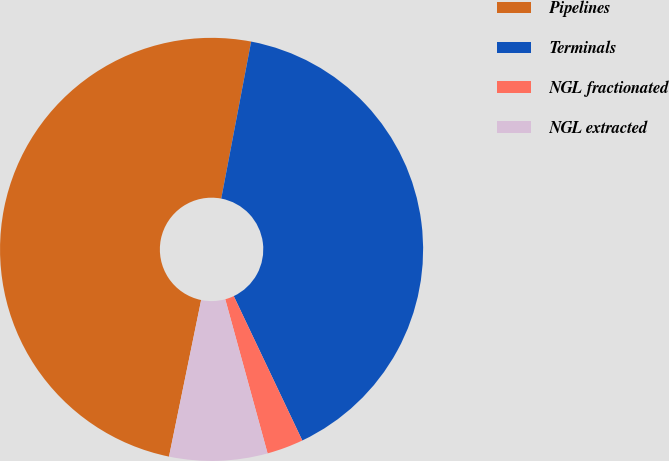Convert chart to OTSL. <chart><loc_0><loc_0><loc_500><loc_500><pie_chart><fcel>Pipelines<fcel>Terminals<fcel>NGL fractionated<fcel>NGL extracted<nl><fcel>49.77%<fcel>39.95%<fcel>2.79%<fcel>7.49%<nl></chart> 